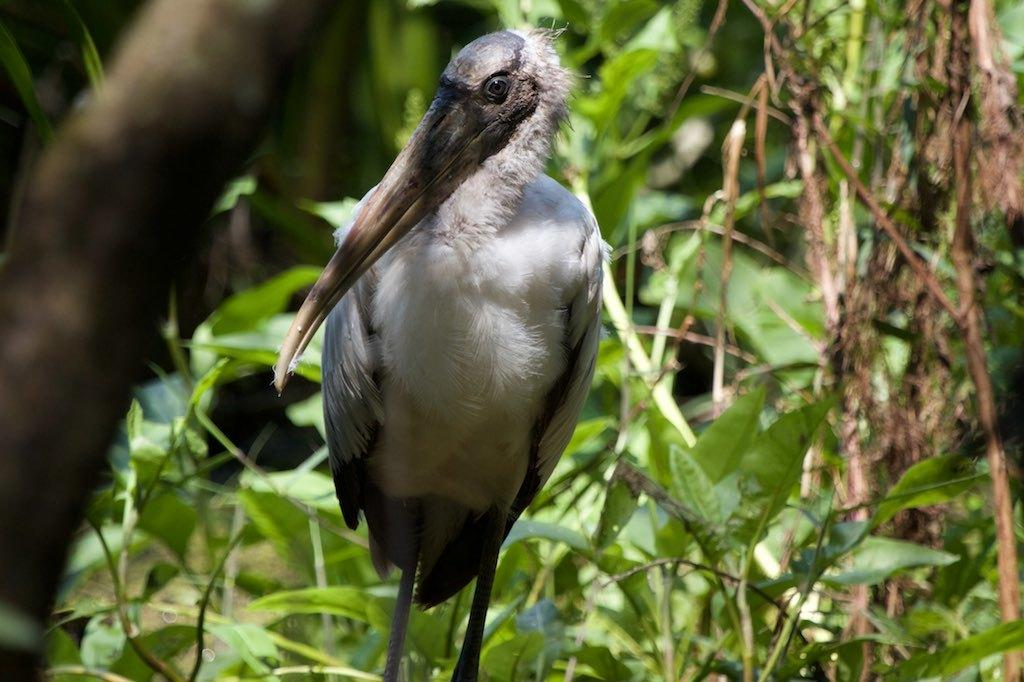Where was the picture taken? The picture was clicked outside. What is the main subject of the image? There is a white color bird in the center of the image. What is the bird doing in the image? The bird is standing. What type of vegetation can be seen in the image? There are green color leaves and dry stems visible in the image. What is visible in the background of the image? There are plants in the background of the image. How many passengers are visible in the image? There are no passengers present in the image; it features a bird and vegetation. Is there a bridge visible in the image? There is no bridge present in the image. 